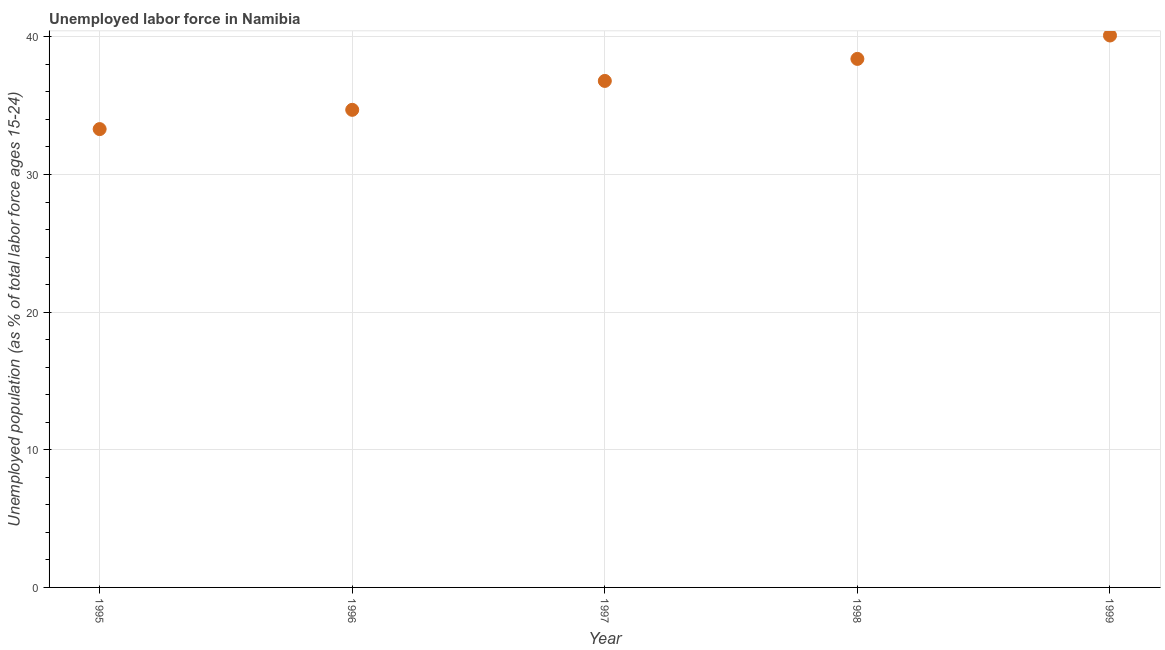What is the total unemployed youth population in 1995?
Your response must be concise. 33.3. Across all years, what is the maximum total unemployed youth population?
Your response must be concise. 40.1. Across all years, what is the minimum total unemployed youth population?
Provide a succinct answer. 33.3. In which year was the total unemployed youth population maximum?
Make the answer very short. 1999. In which year was the total unemployed youth population minimum?
Give a very brief answer. 1995. What is the sum of the total unemployed youth population?
Offer a terse response. 183.3. What is the difference between the total unemployed youth population in 1997 and 1998?
Ensure brevity in your answer.  -1.6. What is the average total unemployed youth population per year?
Provide a short and direct response. 36.66. What is the median total unemployed youth population?
Your answer should be very brief. 36.8. What is the ratio of the total unemployed youth population in 1995 to that in 1997?
Offer a terse response. 0.9. Is the difference between the total unemployed youth population in 1997 and 1999 greater than the difference between any two years?
Make the answer very short. No. What is the difference between the highest and the second highest total unemployed youth population?
Keep it short and to the point. 1.7. What is the difference between the highest and the lowest total unemployed youth population?
Make the answer very short. 6.8. Does the total unemployed youth population monotonically increase over the years?
Offer a terse response. Yes. How many dotlines are there?
Offer a very short reply. 1. How many years are there in the graph?
Provide a short and direct response. 5. Does the graph contain any zero values?
Keep it short and to the point. No. What is the title of the graph?
Keep it short and to the point. Unemployed labor force in Namibia. What is the label or title of the Y-axis?
Provide a succinct answer. Unemployed population (as % of total labor force ages 15-24). What is the Unemployed population (as % of total labor force ages 15-24) in 1995?
Make the answer very short. 33.3. What is the Unemployed population (as % of total labor force ages 15-24) in 1996?
Keep it short and to the point. 34.7. What is the Unemployed population (as % of total labor force ages 15-24) in 1997?
Give a very brief answer. 36.8. What is the Unemployed population (as % of total labor force ages 15-24) in 1998?
Provide a succinct answer. 38.4. What is the Unemployed population (as % of total labor force ages 15-24) in 1999?
Offer a very short reply. 40.1. What is the difference between the Unemployed population (as % of total labor force ages 15-24) in 1995 and 1997?
Your answer should be very brief. -3.5. What is the difference between the Unemployed population (as % of total labor force ages 15-24) in 1995 and 1999?
Make the answer very short. -6.8. What is the difference between the Unemployed population (as % of total labor force ages 15-24) in 1996 and 1998?
Give a very brief answer. -3.7. What is the difference between the Unemployed population (as % of total labor force ages 15-24) in 1997 and 1998?
Provide a short and direct response. -1.6. What is the ratio of the Unemployed population (as % of total labor force ages 15-24) in 1995 to that in 1996?
Provide a succinct answer. 0.96. What is the ratio of the Unemployed population (as % of total labor force ages 15-24) in 1995 to that in 1997?
Your answer should be compact. 0.91. What is the ratio of the Unemployed population (as % of total labor force ages 15-24) in 1995 to that in 1998?
Provide a short and direct response. 0.87. What is the ratio of the Unemployed population (as % of total labor force ages 15-24) in 1995 to that in 1999?
Keep it short and to the point. 0.83. What is the ratio of the Unemployed population (as % of total labor force ages 15-24) in 1996 to that in 1997?
Your answer should be compact. 0.94. What is the ratio of the Unemployed population (as % of total labor force ages 15-24) in 1996 to that in 1998?
Your answer should be compact. 0.9. What is the ratio of the Unemployed population (as % of total labor force ages 15-24) in 1996 to that in 1999?
Offer a very short reply. 0.86. What is the ratio of the Unemployed population (as % of total labor force ages 15-24) in 1997 to that in 1998?
Provide a succinct answer. 0.96. What is the ratio of the Unemployed population (as % of total labor force ages 15-24) in 1997 to that in 1999?
Your response must be concise. 0.92. What is the ratio of the Unemployed population (as % of total labor force ages 15-24) in 1998 to that in 1999?
Provide a short and direct response. 0.96. 